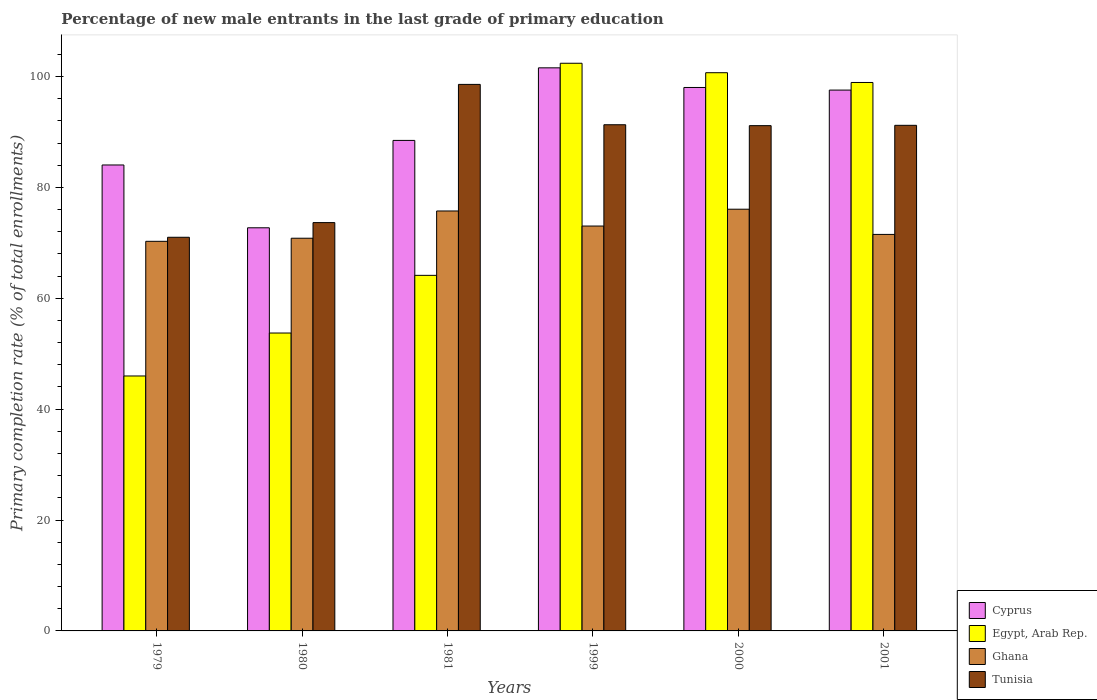How many different coloured bars are there?
Your response must be concise. 4. What is the percentage of new male entrants in Tunisia in 1999?
Give a very brief answer. 91.3. Across all years, what is the maximum percentage of new male entrants in Cyprus?
Ensure brevity in your answer.  101.57. Across all years, what is the minimum percentage of new male entrants in Tunisia?
Provide a short and direct response. 71.01. In which year was the percentage of new male entrants in Cyprus maximum?
Offer a terse response. 1999. In which year was the percentage of new male entrants in Ghana minimum?
Your answer should be compact. 1979. What is the total percentage of new male entrants in Egypt, Arab Rep. in the graph?
Keep it short and to the point. 465.86. What is the difference between the percentage of new male entrants in Tunisia in 1980 and that in 2001?
Your answer should be very brief. -17.55. What is the difference between the percentage of new male entrants in Cyprus in 2000 and the percentage of new male entrants in Egypt, Arab Rep. in 2001?
Offer a terse response. -0.9. What is the average percentage of new male entrants in Cyprus per year?
Ensure brevity in your answer.  90.4. In the year 1999, what is the difference between the percentage of new male entrants in Cyprus and percentage of new male entrants in Ghana?
Provide a succinct answer. 28.54. In how many years, is the percentage of new male entrants in Egypt, Arab Rep. greater than 4 %?
Keep it short and to the point. 6. What is the ratio of the percentage of new male entrants in Tunisia in 1979 to that in 2000?
Give a very brief answer. 0.78. Is the percentage of new male entrants in Ghana in 1980 less than that in 1981?
Your answer should be very brief. Yes. What is the difference between the highest and the second highest percentage of new male entrants in Egypt, Arab Rep.?
Your answer should be compact. 1.71. What is the difference between the highest and the lowest percentage of new male entrants in Ghana?
Give a very brief answer. 5.79. Is it the case that in every year, the sum of the percentage of new male entrants in Ghana and percentage of new male entrants in Cyprus is greater than the sum of percentage of new male entrants in Tunisia and percentage of new male entrants in Egypt, Arab Rep.?
Your answer should be very brief. No. How many bars are there?
Your response must be concise. 24. Are all the bars in the graph horizontal?
Offer a very short reply. No. How many years are there in the graph?
Provide a succinct answer. 6. Are the values on the major ticks of Y-axis written in scientific E-notation?
Your answer should be compact. No. Does the graph contain any zero values?
Ensure brevity in your answer.  No. Where does the legend appear in the graph?
Provide a short and direct response. Bottom right. How many legend labels are there?
Your response must be concise. 4. What is the title of the graph?
Your answer should be very brief. Percentage of new male entrants in the last grade of primary education. Does "Chile" appear as one of the legend labels in the graph?
Ensure brevity in your answer.  No. What is the label or title of the X-axis?
Ensure brevity in your answer.  Years. What is the label or title of the Y-axis?
Your answer should be compact. Primary completion rate (% of total enrollments). What is the Primary completion rate (% of total enrollments) of Cyprus in 1979?
Ensure brevity in your answer.  84.04. What is the Primary completion rate (% of total enrollments) of Egypt, Arab Rep. in 1979?
Your answer should be very brief. 45.99. What is the Primary completion rate (% of total enrollments) of Ghana in 1979?
Give a very brief answer. 70.28. What is the Primary completion rate (% of total enrollments) in Tunisia in 1979?
Provide a succinct answer. 71.01. What is the Primary completion rate (% of total enrollments) of Cyprus in 1980?
Your response must be concise. 72.72. What is the Primary completion rate (% of total enrollments) in Egypt, Arab Rep. in 1980?
Your answer should be very brief. 53.73. What is the Primary completion rate (% of total enrollments) of Ghana in 1980?
Offer a very short reply. 70.83. What is the Primary completion rate (% of total enrollments) in Tunisia in 1980?
Your answer should be very brief. 73.65. What is the Primary completion rate (% of total enrollments) in Cyprus in 1981?
Ensure brevity in your answer.  88.48. What is the Primary completion rate (% of total enrollments) in Egypt, Arab Rep. in 1981?
Provide a succinct answer. 64.14. What is the Primary completion rate (% of total enrollments) of Ghana in 1981?
Offer a terse response. 75.75. What is the Primary completion rate (% of total enrollments) of Tunisia in 1981?
Provide a short and direct response. 98.58. What is the Primary completion rate (% of total enrollments) in Cyprus in 1999?
Your answer should be very brief. 101.57. What is the Primary completion rate (% of total enrollments) of Egypt, Arab Rep. in 1999?
Provide a short and direct response. 102.39. What is the Primary completion rate (% of total enrollments) of Ghana in 1999?
Your answer should be very brief. 73.03. What is the Primary completion rate (% of total enrollments) in Tunisia in 1999?
Ensure brevity in your answer.  91.3. What is the Primary completion rate (% of total enrollments) of Cyprus in 2000?
Give a very brief answer. 98.03. What is the Primary completion rate (% of total enrollments) of Egypt, Arab Rep. in 2000?
Ensure brevity in your answer.  100.69. What is the Primary completion rate (% of total enrollments) of Ghana in 2000?
Keep it short and to the point. 76.07. What is the Primary completion rate (% of total enrollments) in Tunisia in 2000?
Keep it short and to the point. 91.14. What is the Primary completion rate (% of total enrollments) of Cyprus in 2001?
Make the answer very short. 97.55. What is the Primary completion rate (% of total enrollments) of Egypt, Arab Rep. in 2001?
Your response must be concise. 98.93. What is the Primary completion rate (% of total enrollments) of Ghana in 2001?
Give a very brief answer. 71.52. What is the Primary completion rate (% of total enrollments) in Tunisia in 2001?
Provide a succinct answer. 91.2. Across all years, what is the maximum Primary completion rate (% of total enrollments) of Cyprus?
Provide a short and direct response. 101.57. Across all years, what is the maximum Primary completion rate (% of total enrollments) of Egypt, Arab Rep.?
Keep it short and to the point. 102.39. Across all years, what is the maximum Primary completion rate (% of total enrollments) in Ghana?
Your response must be concise. 76.07. Across all years, what is the maximum Primary completion rate (% of total enrollments) in Tunisia?
Keep it short and to the point. 98.58. Across all years, what is the minimum Primary completion rate (% of total enrollments) of Cyprus?
Make the answer very short. 72.72. Across all years, what is the minimum Primary completion rate (% of total enrollments) of Egypt, Arab Rep.?
Make the answer very short. 45.99. Across all years, what is the minimum Primary completion rate (% of total enrollments) of Ghana?
Provide a short and direct response. 70.28. Across all years, what is the minimum Primary completion rate (% of total enrollments) of Tunisia?
Provide a short and direct response. 71.01. What is the total Primary completion rate (% of total enrollments) of Cyprus in the graph?
Offer a very short reply. 542.39. What is the total Primary completion rate (% of total enrollments) in Egypt, Arab Rep. in the graph?
Give a very brief answer. 465.86. What is the total Primary completion rate (% of total enrollments) in Ghana in the graph?
Make the answer very short. 437.48. What is the total Primary completion rate (% of total enrollments) of Tunisia in the graph?
Provide a short and direct response. 516.88. What is the difference between the Primary completion rate (% of total enrollments) of Cyprus in 1979 and that in 1980?
Ensure brevity in your answer.  11.33. What is the difference between the Primary completion rate (% of total enrollments) in Egypt, Arab Rep. in 1979 and that in 1980?
Offer a very short reply. -7.75. What is the difference between the Primary completion rate (% of total enrollments) in Ghana in 1979 and that in 1980?
Keep it short and to the point. -0.56. What is the difference between the Primary completion rate (% of total enrollments) of Tunisia in 1979 and that in 1980?
Your answer should be compact. -2.65. What is the difference between the Primary completion rate (% of total enrollments) of Cyprus in 1979 and that in 1981?
Your answer should be compact. -4.43. What is the difference between the Primary completion rate (% of total enrollments) of Egypt, Arab Rep. in 1979 and that in 1981?
Your answer should be compact. -18.15. What is the difference between the Primary completion rate (% of total enrollments) of Ghana in 1979 and that in 1981?
Offer a terse response. -5.47. What is the difference between the Primary completion rate (% of total enrollments) in Tunisia in 1979 and that in 1981?
Provide a short and direct response. -27.58. What is the difference between the Primary completion rate (% of total enrollments) of Cyprus in 1979 and that in 1999?
Give a very brief answer. -17.52. What is the difference between the Primary completion rate (% of total enrollments) in Egypt, Arab Rep. in 1979 and that in 1999?
Provide a short and direct response. -56.41. What is the difference between the Primary completion rate (% of total enrollments) of Ghana in 1979 and that in 1999?
Your answer should be very brief. -2.76. What is the difference between the Primary completion rate (% of total enrollments) in Tunisia in 1979 and that in 1999?
Give a very brief answer. -20.3. What is the difference between the Primary completion rate (% of total enrollments) of Cyprus in 1979 and that in 2000?
Your response must be concise. -13.98. What is the difference between the Primary completion rate (% of total enrollments) of Egypt, Arab Rep. in 1979 and that in 2000?
Your answer should be compact. -54.7. What is the difference between the Primary completion rate (% of total enrollments) in Ghana in 1979 and that in 2000?
Make the answer very short. -5.79. What is the difference between the Primary completion rate (% of total enrollments) in Tunisia in 1979 and that in 2000?
Give a very brief answer. -20.13. What is the difference between the Primary completion rate (% of total enrollments) of Cyprus in 1979 and that in 2001?
Your answer should be very brief. -13.51. What is the difference between the Primary completion rate (% of total enrollments) of Egypt, Arab Rep. in 1979 and that in 2001?
Your response must be concise. -52.94. What is the difference between the Primary completion rate (% of total enrollments) of Ghana in 1979 and that in 2001?
Make the answer very short. -1.25. What is the difference between the Primary completion rate (% of total enrollments) in Tunisia in 1979 and that in 2001?
Offer a terse response. -20.19. What is the difference between the Primary completion rate (% of total enrollments) in Cyprus in 1980 and that in 1981?
Provide a succinct answer. -15.76. What is the difference between the Primary completion rate (% of total enrollments) of Egypt, Arab Rep. in 1980 and that in 1981?
Offer a terse response. -10.4. What is the difference between the Primary completion rate (% of total enrollments) in Ghana in 1980 and that in 1981?
Your answer should be very brief. -4.92. What is the difference between the Primary completion rate (% of total enrollments) in Tunisia in 1980 and that in 1981?
Provide a succinct answer. -24.93. What is the difference between the Primary completion rate (% of total enrollments) in Cyprus in 1980 and that in 1999?
Offer a very short reply. -28.85. What is the difference between the Primary completion rate (% of total enrollments) in Egypt, Arab Rep. in 1980 and that in 1999?
Ensure brevity in your answer.  -48.66. What is the difference between the Primary completion rate (% of total enrollments) of Ghana in 1980 and that in 1999?
Provide a short and direct response. -2.2. What is the difference between the Primary completion rate (% of total enrollments) in Tunisia in 1980 and that in 1999?
Your answer should be compact. -17.65. What is the difference between the Primary completion rate (% of total enrollments) of Cyprus in 1980 and that in 2000?
Keep it short and to the point. -25.31. What is the difference between the Primary completion rate (% of total enrollments) of Egypt, Arab Rep. in 1980 and that in 2000?
Offer a terse response. -46.95. What is the difference between the Primary completion rate (% of total enrollments) of Ghana in 1980 and that in 2000?
Provide a succinct answer. -5.23. What is the difference between the Primary completion rate (% of total enrollments) of Tunisia in 1980 and that in 2000?
Offer a very short reply. -17.49. What is the difference between the Primary completion rate (% of total enrollments) in Cyprus in 1980 and that in 2001?
Provide a succinct answer. -24.84. What is the difference between the Primary completion rate (% of total enrollments) in Egypt, Arab Rep. in 1980 and that in 2001?
Provide a succinct answer. -45.19. What is the difference between the Primary completion rate (% of total enrollments) in Ghana in 1980 and that in 2001?
Provide a succinct answer. -0.69. What is the difference between the Primary completion rate (% of total enrollments) of Tunisia in 1980 and that in 2001?
Your answer should be very brief. -17.55. What is the difference between the Primary completion rate (% of total enrollments) of Cyprus in 1981 and that in 1999?
Your answer should be very brief. -13.09. What is the difference between the Primary completion rate (% of total enrollments) in Egypt, Arab Rep. in 1981 and that in 1999?
Offer a very short reply. -38.26. What is the difference between the Primary completion rate (% of total enrollments) of Ghana in 1981 and that in 1999?
Keep it short and to the point. 2.72. What is the difference between the Primary completion rate (% of total enrollments) in Tunisia in 1981 and that in 1999?
Ensure brevity in your answer.  7.28. What is the difference between the Primary completion rate (% of total enrollments) of Cyprus in 1981 and that in 2000?
Offer a very short reply. -9.55. What is the difference between the Primary completion rate (% of total enrollments) in Egypt, Arab Rep. in 1981 and that in 2000?
Give a very brief answer. -36.55. What is the difference between the Primary completion rate (% of total enrollments) of Ghana in 1981 and that in 2000?
Your answer should be very brief. -0.32. What is the difference between the Primary completion rate (% of total enrollments) in Tunisia in 1981 and that in 2000?
Offer a very short reply. 7.44. What is the difference between the Primary completion rate (% of total enrollments) of Cyprus in 1981 and that in 2001?
Provide a short and direct response. -9.08. What is the difference between the Primary completion rate (% of total enrollments) of Egypt, Arab Rep. in 1981 and that in 2001?
Give a very brief answer. -34.79. What is the difference between the Primary completion rate (% of total enrollments) of Ghana in 1981 and that in 2001?
Offer a very short reply. 4.23. What is the difference between the Primary completion rate (% of total enrollments) of Tunisia in 1981 and that in 2001?
Offer a very short reply. 7.38. What is the difference between the Primary completion rate (% of total enrollments) of Cyprus in 1999 and that in 2000?
Give a very brief answer. 3.54. What is the difference between the Primary completion rate (% of total enrollments) of Egypt, Arab Rep. in 1999 and that in 2000?
Ensure brevity in your answer.  1.71. What is the difference between the Primary completion rate (% of total enrollments) in Ghana in 1999 and that in 2000?
Provide a succinct answer. -3.03. What is the difference between the Primary completion rate (% of total enrollments) of Tunisia in 1999 and that in 2000?
Your response must be concise. 0.16. What is the difference between the Primary completion rate (% of total enrollments) of Cyprus in 1999 and that in 2001?
Give a very brief answer. 4.01. What is the difference between the Primary completion rate (% of total enrollments) in Egypt, Arab Rep. in 1999 and that in 2001?
Ensure brevity in your answer.  3.47. What is the difference between the Primary completion rate (% of total enrollments) in Ghana in 1999 and that in 2001?
Your response must be concise. 1.51. What is the difference between the Primary completion rate (% of total enrollments) in Tunisia in 1999 and that in 2001?
Give a very brief answer. 0.1. What is the difference between the Primary completion rate (% of total enrollments) of Cyprus in 2000 and that in 2001?
Provide a succinct answer. 0.47. What is the difference between the Primary completion rate (% of total enrollments) in Egypt, Arab Rep. in 2000 and that in 2001?
Provide a short and direct response. 1.76. What is the difference between the Primary completion rate (% of total enrollments) of Ghana in 2000 and that in 2001?
Offer a terse response. 4.54. What is the difference between the Primary completion rate (% of total enrollments) in Tunisia in 2000 and that in 2001?
Your answer should be compact. -0.06. What is the difference between the Primary completion rate (% of total enrollments) of Cyprus in 1979 and the Primary completion rate (% of total enrollments) of Egypt, Arab Rep. in 1980?
Make the answer very short. 30.31. What is the difference between the Primary completion rate (% of total enrollments) of Cyprus in 1979 and the Primary completion rate (% of total enrollments) of Ghana in 1980?
Offer a very short reply. 13.21. What is the difference between the Primary completion rate (% of total enrollments) of Cyprus in 1979 and the Primary completion rate (% of total enrollments) of Tunisia in 1980?
Your answer should be very brief. 10.39. What is the difference between the Primary completion rate (% of total enrollments) of Egypt, Arab Rep. in 1979 and the Primary completion rate (% of total enrollments) of Ghana in 1980?
Give a very brief answer. -24.85. What is the difference between the Primary completion rate (% of total enrollments) of Egypt, Arab Rep. in 1979 and the Primary completion rate (% of total enrollments) of Tunisia in 1980?
Ensure brevity in your answer.  -27.67. What is the difference between the Primary completion rate (% of total enrollments) in Ghana in 1979 and the Primary completion rate (% of total enrollments) in Tunisia in 1980?
Your answer should be compact. -3.38. What is the difference between the Primary completion rate (% of total enrollments) in Cyprus in 1979 and the Primary completion rate (% of total enrollments) in Egypt, Arab Rep. in 1981?
Ensure brevity in your answer.  19.91. What is the difference between the Primary completion rate (% of total enrollments) of Cyprus in 1979 and the Primary completion rate (% of total enrollments) of Ghana in 1981?
Your response must be concise. 8.3. What is the difference between the Primary completion rate (% of total enrollments) of Cyprus in 1979 and the Primary completion rate (% of total enrollments) of Tunisia in 1981?
Your answer should be compact. -14.54. What is the difference between the Primary completion rate (% of total enrollments) in Egypt, Arab Rep. in 1979 and the Primary completion rate (% of total enrollments) in Ghana in 1981?
Your response must be concise. -29.76. What is the difference between the Primary completion rate (% of total enrollments) in Egypt, Arab Rep. in 1979 and the Primary completion rate (% of total enrollments) in Tunisia in 1981?
Provide a succinct answer. -52.6. What is the difference between the Primary completion rate (% of total enrollments) of Ghana in 1979 and the Primary completion rate (% of total enrollments) of Tunisia in 1981?
Offer a very short reply. -28.31. What is the difference between the Primary completion rate (% of total enrollments) in Cyprus in 1979 and the Primary completion rate (% of total enrollments) in Egypt, Arab Rep. in 1999?
Provide a succinct answer. -18.35. What is the difference between the Primary completion rate (% of total enrollments) in Cyprus in 1979 and the Primary completion rate (% of total enrollments) in Ghana in 1999?
Provide a short and direct response. 11.01. What is the difference between the Primary completion rate (% of total enrollments) of Cyprus in 1979 and the Primary completion rate (% of total enrollments) of Tunisia in 1999?
Keep it short and to the point. -7.26. What is the difference between the Primary completion rate (% of total enrollments) of Egypt, Arab Rep. in 1979 and the Primary completion rate (% of total enrollments) of Ghana in 1999?
Offer a terse response. -27.05. What is the difference between the Primary completion rate (% of total enrollments) in Egypt, Arab Rep. in 1979 and the Primary completion rate (% of total enrollments) in Tunisia in 1999?
Offer a very short reply. -45.32. What is the difference between the Primary completion rate (% of total enrollments) in Ghana in 1979 and the Primary completion rate (% of total enrollments) in Tunisia in 1999?
Keep it short and to the point. -21.03. What is the difference between the Primary completion rate (% of total enrollments) in Cyprus in 1979 and the Primary completion rate (% of total enrollments) in Egypt, Arab Rep. in 2000?
Provide a short and direct response. -16.64. What is the difference between the Primary completion rate (% of total enrollments) in Cyprus in 1979 and the Primary completion rate (% of total enrollments) in Ghana in 2000?
Keep it short and to the point. 7.98. What is the difference between the Primary completion rate (% of total enrollments) in Cyprus in 1979 and the Primary completion rate (% of total enrollments) in Tunisia in 2000?
Make the answer very short. -7.09. What is the difference between the Primary completion rate (% of total enrollments) of Egypt, Arab Rep. in 1979 and the Primary completion rate (% of total enrollments) of Ghana in 2000?
Ensure brevity in your answer.  -30.08. What is the difference between the Primary completion rate (% of total enrollments) of Egypt, Arab Rep. in 1979 and the Primary completion rate (% of total enrollments) of Tunisia in 2000?
Offer a terse response. -45.15. What is the difference between the Primary completion rate (% of total enrollments) of Ghana in 1979 and the Primary completion rate (% of total enrollments) of Tunisia in 2000?
Offer a very short reply. -20.86. What is the difference between the Primary completion rate (% of total enrollments) in Cyprus in 1979 and the Primary completion rate (% of total enrollments) in Egypt, Arab Rep. in 2001?
Provide a succinct answer. -14.88. What is the difference between the Primary completion rate (% of total enrollments) of Cyprus in 1979 and the Primary completion rate (% of total enrollments) of Ghana in 2001?
Offer a terse response. 12.52. What is the difference between the Primary completion rate (% of total enrollments) in Cyprus in 1979 and the Primary completion rate (% of total enrollments) in Tunisia in 2001?
Offer a terse response. -7.16. What is the difference between the Primary completion rate (% of total enrollments) in Egypt, Arab Rep. in 1979 and the Primary completion rate (% of total enrollments) in Ghana in 2001?
Provide a succinct answer. -25.54. What is the difference between the Primary completion rate (% of total enrollments) of Egypt, Arab Rep. in 1979 and the Primary completion rate (% of total enrollments) of Tunisia in 2001?
Provide a succinct answer. -45.21. What is the difference between the Primary completion rate (% of total enrollments) in Ghana in 1979 and the Primary completion rate (% of total enrollments) in Tunisia in 2001?
Your response must be concise. -20.92. What is the difference between the Primary completion rate (% of total enrollments) in Cyprus in 1980 and the Primary completion rate (% of total enrollments) in Egypt, Arab Rep. in 1981?
Ensure brevity in your answer.  8.58. What is the difference between the Primary completion rate (% of total enrollments) in Cyprus in 1980 and the Primary completion rate (% of total enrollments) in Ghana in 1981?
Make the answer very short. -3.03. What is the difference between the Primary completion rate (% of total enrollments) of Cyprus in 1980 and the Primary completion rate (% of total enrollments) of Tunisia in 1981?
Provide a succinct answer. -25.86. What is the difference between the Primary completion rate (% of total enrollments) in Egypt, Arab Rep. in 1980 and the Primary completion rate (% of total enrollments) in Ghana in 1981?
Ensure brevity in your answer.  -22.01. What is the difference between the Primary completion rate (% of total enrollments) of Egypt, Arab Rep. in 1980 and the Primary completion rate (% of total enrollments) of Tunisia in 1981?
Ensure brevity in your answer.  -44.85. What is the difference between the Primary completion rate (% of total enrollments) of Ghana in 1980 and the Primary completion rate (% of total enrollments) of Tunisia in 1981?
Make the answer very short. -27.75. What is the difference between the Primary completion rate (% of total enrollments) in Cyprus in 1980 and the Primary completion rate (% of total enrollments) in Egypt, Arab Rep. in 1999?
Make the answer very short. -29.68. What is the difference between the Primary completion rate (% of total enrollments) of Cyprus in 1980 and the Primary completion rate (% of total enrollments) of Ghana in 1999?
Provide a short and direct response. -0.32. What is the difference between the Primary completion rate (% of total enrollments) in Cyprus in 1980 and the Primary completion rate (% of total enrollments) in Tunisia in 1999?
Your answer should be very brief. -18.59. What is the difference between the Primary completion rate (% of total enrollments) of Egypt, Arab Rep. in 1980 and the Primary completion rate (% of total enrollments) of Ghana in 1999?
Your answer should be very brief. -19.3. What is the difference between the Primary completion rate (% of total enrollments) in Egypt, Arab Rep. in 1980 and the Primary completion rate (% of total enrollments) in Tunisia in 1999?
Your answer should be compact. -37.57. What is the difference between the Primary completion rate (% of total enrollments) in Ghana in 1980 and the Primary completion rate (% of total enrollments) in Tunisia in 1999?
Provide a short and direct response. -20.47. What is the difference between the Primary completion rate (% of total enrollments) in Cyprus in 1980 and the Primary completion rate (% of total enrollments) in Egypt, Arab Rep. in 2000?
Offer a terse response. -27.97. What is the difference between the Primary completion rate (% of total enrollments) of Cyprus in 1980 and the Primary completion rate (% of total enrollments) of Ghana in 2000?
Your response must be concise. -3.35. What is the difference between the Primary completion rate (% of total enrollments) in Cyprus in 1980 and the Primary completion rate (% of total enrollments) in Tunisia in 2000?
Provide a short and direct response. -18.42. What is the difference between the Primary completion rate (% of total enrollments) in Egypt, Arab Rep. in 1980 and the Primary completion rate (% of total enrollments) in Ghana in 2000?
Offer a terse response. -22.33. What is the difference between the Primary completion rate (% of total enrollments) in Egypt, Arab Rep. in 1980 and the Primary completion rate (% of total enrollments) in Tunisia in 2000?
Ensure brevity in your answer.  -37.41. What is the difference between the Primary completion rate (% of total enrollments) in Ghana in 1980 and the Primary completion rate (% of total enrollments) in Tunisia in 2000?
Give a very brief answer. -20.31. What is the difference between the Primary completion rate (% of total enrollments) of Cyprus in 1980 and the Primary completion rate (% of total enrollments) of Egypt, Arab Rep. in 2001?
Ensure brevity in your answer.  -26.21. What is the difference between the Primary completion rate (% of total enrollments) of Cyprus in 1980 and the Primary completion rate (% of total enrollments) of Ghana in 2001?
Make the answer very short. 1.19. What is the difference between the Primary completion rate (% of total enrollments) of Cyprus in 1980 and the Primary completion rate (% of total enrollments) of Tunisia in 2001?
Give a very brief answer. -18.48. What is the difference between the Primary completion rate (% of total enrollments) in Egypt, Arab Rep. in 1980 and the Primary completion rate (% of total enrollments) in Ghana in 2001?
Make the answer very short. -17.79. What is the difference between the Primary completion rate (% of total enrollments) of Egypt, Arab Rep. in 1980 and the Primary completion rate (% of total enrollments) of Tunisia in 2001?
Make the answer very short. -37.47. What is the difference between the Primary completion rate (% of total enrollments) of Ghana in 1980 and the Primary completion rate (% of total enrollments) of Tunisia in 2001?
Offer a very short reply. -20.37. What is the difference between the Primary completion rate (% of total enrollments) in Cyprus in 1981 and the Primary completion rate (% of total enrollments) in Egypt, Arab Rep. in 1999?
Ensure brevity in your answer.  -13.92. What is the difference between the Primary completion rate (% of total enrollments) in Cyprus in 1981 and the Primary completion rate (% of total enrollments) in Ghana in 1999?
Your answer should be compact. 15.44. What is the difference between the Primary completion rate (% of total enrollments) of Cyprus in 1981 and the Primary completion rate (% of total enrollments) of Tunisia in 1999?
Give a very brief answer. -2.83. What is the difference between the Primary completion rate (% of total enrollments) in Egypt, Arab Rep. in 1981 and the Primary completion rate (% of total enrollments) in Ghana in 1999?
Your answer should be very brief. -8.9. What is the difference between the Primary completion rate (% of total enrollments) in Egypt, Arab Rep. in 1981 and the Primary completion rate (% of total enrollments) in Tunisia in 1999?
Your answer should be very brief. -27.17. What is the difference between the Primary completion rate (% of total enrollments) of Ghana in 1981 and the Primary completion rate (% of total enrollments) of Tunisia in 1999?
Give a very brief answer. -15.55. What is the difference between the Primary completion rate (% of total enrollments) in Cyprus in 1981 and the Primary completion rate (% of total enrollments) in Egypt, Arab Rep. in 2000?
Keep it short and to the point. -12.21. What is the difference between the Primary completion rate (% of total enrollments) of Cyprus in 1981 and the Primary completion rate (% of total enrollments) of Ghana in 2000?
Your answer should be very brief. 12.41. What is the difference between the Primary completion rate (% of total enrollments) in Cyprus in 1981 and the Primary completion rate (% of total enrollments) in Tunisia in 2000?
Your answer should be very brief. -2.66. What is the difference between the Primary completion rate (% of total enrollments) in Egypt, Arab Rep. in 1981 and the Primary completion rate (% of total enrollments) in Ghana in 2000?
Make the answer very short. -11.93. What is the difference between the Primary completion rate (% of total enrollments) of Egypt, Arab Rep. in 1981 and the Primary completion rate (% of total enrollments) of Tunisia in 2000?
Your answer should be compact. -27. What is the difference between the Primary completion rate (% of total enrollments) in Ghana in 1981 and the Primary completion rate (% of total enrollments) in Tunisia in 2000?
Keep it short and to the point. -15.39. What is the difference between the Primary completion rate (% of total enrollments) of Cyprus in 1981 and the Primary completion rate (% of total enrollments) of Egypt, Arab Rep. in 2001?
Give a very brief answer. -10.45. What is the difference between the Primary completion rate (% of total enrollments) of Cyprus in 1981 and the Primary completion rate (% of total enrollments) of Ghana in 2001?
Provide a succinct answer. 16.95. What is the difference between the Primary completion rate (% of total enrollments) in Cyprus in 1981 and the Primary completion rate (% of total enrollments) in Tunisia in 2001?
Your answer should be compact. -2.72. What is the difference between the Primary completion rate (% of total enrollments) of Egypt, Arab Rep. in 1981 and the Primary completion rate (% of total enrollments) of Ghana in 2001?
Offer a terse response. -7.39. What is the difference between the Primary completion rate (% of total enrollments) in Egypt, Arab Rep. in 1981 and the Primary completion rate (% of total enrollments) in Tunisia in 2001?
Your answer should be compact. -27.06. What is the difference between the Primary completion rate (% of total enrollments) in Ghana in 1981 and the Primary completion rate (% of total enrollments) in Tunisia in 2001?
Offer a very short reply. -15.45. What is the difference between the Primary completion rate (% of total enrollments) of Cyprus in 1999 and the Primary completion rate (% of total enrollments) of Egypt, Arab Rep. in 2000?
Keep it short and to the point. 0.88. What is the difference between the Primary completion rate (% of total enrollments) in Cyprus in 1999 and the Primary completion rate (% of total enrollments) in Ghana in 2000?
Offer a very short reply. 25.5. What is the difference between the Primary completion rate (% of total enrollments) in Cyprus in 1999 and the Primary completion rate (% of total enrollments) in Tunisia in 2000?
Provide a short and direct response. 10.43. What is the difference between the Primary completion rate (% of total enrollments) in Egypt, Arab Rep. in 1999 and the Primary completion rate (% of total enrollments) in Ghana in 2000?
Your answer should be compact. 26.33. What is the difference between the Primary completion rate (% of total enrollments) in Egypt, Arab Rep. in 1999 and the Primary completion rate (% of total enrollments) in Tunisia in 2000?
Your answer should be compact. 11.25. What is the difference between the Primary completion rate (% of total enrollments) of Ghana in 1999 and the Primary completion rate (% of total enrollments) of Tunisia in 2000?
Ensure brevity in your answer.  -18.11. What is the difference between the Primary completion rate (% of total enrollments) in Cyprus in 1999 and the Primary completion rate (% of total enrollments) in Egypt, Arab Rep. in 2001?
Your response must be concise. 2.64. What is the difference between the Primary completion rate (% of total enrollments) of Cyprus in 1999 and the Primary completion rate (% of total enrollments) of Ghana in 2001?
Your response must be concise. 30.05. What is the difference between the Primary completion rate (% of total enrollments) of Cyprus in 1999 and the Primary completion rate (% of total enrollments) of Tunisia in 2001?
Provide a short and direct response. 10.37. What is the difference between the Primary completion rate (% of total enrollments) of Egypt, Arab Rep. in 1999 and the Primary completion rate (% of total enrollments) of Ghana in 2001?
Provide a short and direct response. 30.87. What is the difference between the Primary completion rate (% of total enrollments) in Egypt, Arab Rep. in 1999 and the Primary completion rate (% of total enrollments) in Tunisia in 2001?
Offer a terse response. 11.19. What is the difference between the Primary completion rate (% of total enrollments) in Ghana in 1999 and the Primary completion rate (% of total enrollments) in Tunisia in 2001?
Offer a terse response. -18.17. What is the difference between the Primary completion rate (% of total enrollments) in Cyprus in 2000 and the Primary completion rate (% of total enrollments) in Egypt, Arab Rep. in 2001?
Your response must be concise. -0.9. What is the difference between the Primary completion rate (% of total enrollments) in Cyprus in 2000 and the Primary completion rate (% of total enrollments) in Ghana in 2001?
Your answer should be compact. 26.5. What is the difference between the Primary completion rate (% of total enrollments) of Cyprus in 2000 and the Primary completion rate (% of total enrollments) of Tunisia in 2001?
Ensure brevity in your answer.  6.83. What is the difference between the Primary completion rate (% of total enrollments) of Egypt, Arab Rep. in 2000 and the Primary completion rate (% of total enrollments) of Ghana in 2001?
Your answer should be compact. 29.17. What is the difference between the Primary completion rate (% of total enrollments) of Egypt, Arab Rep. in 2000 and the Primary completion rate (% of total enrollments) of Tunisia in 2001?
Offer a very short reply. 9.49. What is the difference between the Primary completion rate (% of total enrollments) of Ghana in 2000 and the Primary completion rate (% of total enrollments) of Tunisia in 2001?
Keep it short and to the point. -15.13. What is the average Primary completion rate (% of total enrollments) in Cyprus per year?
Your answer should be very brief. 90.4. What is the average Primary completion rate (% of total enrollments) of Egypt, Arab Rep. per year?
Keep it short and to the point. 77.64. What is the average Primary completion rate (% of total enrollments) of Ghana per year?
Your response must be concise. 72.91. What is the average Primary completion rate (% of total enrollments) of Tunisia per year?
Your answer should be very brief. 86.15. In the year 1979, what is the difference between the Primary completion rate (% of total enrollments) of Cyprus and Primary completion rate (% of total enrollments) of Egypt, Arab Rep.?
Ensure brevity in your answer.  38.06. In the year 1979, what is the difference between the Primary completion rate (% of total enrollments) in Cyprus and Primary completion rate (% of total enrollments) in Ghana?
Offer a terse response. 13.77. In the year 1979, what is the difference between the Primary completion rate (% of total enrollments) of Cyprus and Primary completion rate (% of total enrollments) of Tunisia?
Your response must be concise. 13.04. In the year 1979, what is the difference between the Primary completion rate (% of total enrollments) of Egypt, Arab Rep. and Primary completion rate (% of total enrollments) of Ghana?
Your answer should be compact. -24.29. In the year 1979, what is the difference between the Primary completion rate (% of total enrollments) in Egypt, Arab Rep. and Primary completion rate (% of total enrollments) in Tunisia?
Give a very brief answer. -25.02. In the year 1979, what is the difference between the Primary completion rate (% of total enrollments) of Ghana and Primary completion rate (% of total enrollments) of Tunisia?
Your answer should be very brief. -0.73. In the year 1980, what is the difference between the Primary completion rate (% of total enrollments) in Cyprus and Primary completion rate (% of total enrollments) in Egypt, Arab Rep.?
Offer a terse response. 18.98. In the year 1980, what is the difference between the Primary completion rate (% of total enrollments) of Cyprus and Primary completion rate (% of total enrollments) of Ghana?
Give a very brief answer. 1.88. In the year 1980, what is the difference between the Primary completion rate (% of total enrollments) in Cyprus and Primary completion rate (% of total enrollments) in Tunisia?
Ensure brevity in your answer.  -0.94. In the year 1980, what is the difference between the Primary completion rate (% of total enrollments) of Egypt, Arab Rep. and Primary completion rate (% of total enrollments) of Ghana?
Make the answer very short. -17.1. In the year 1980, what is the difference between the Primary completion rate (% of total enrollments) of Egypt, Arab Rep. and Primary completion rate (% of total enrollments) of Tunisia?
Offer a very short reply. -19.92. In the year 1980, what is the difference between the Primary completion rate (% of total enrollments) of Ghana and Primary completion rate (% of total enrollments) of Tunisia?
Keep it short and to the point. -2.82. In the year 1981, what is the difference between the Primary completion rate (% of total enrollments) in Cyprus and Primary completion rate (% of total enrollments) in Egypt, Arab Rep.?
Provide a short and direct response. 24.34. In the year 1981, what is the difference between the Primary completion rate (% of total enrollments) of Cyprus and Primary completion rate (% of total enrollments) of Ghana?
Your answer should be compact. 12.73. In the year 1981, what is the difference between the Primary completion rate (% of total enrollments) of Cyprus and Primary completion rate (% of total enrollments) of Tunisia?
Offer a terse response. -10.11. In the year 1981, what is the difference between the Primary completion rate (% of total enrollments) of Egypt, Arab Rep. and Primary completion rate (% of total enrollments) of Ghana?
Provide a short and direct response. -11.61. In the year 1981, what is the difference between the Primary completion rate (% of total enrollments) of Egypt, Arab Rep. and Primary completion rate (% of total enrollments) of Tunisia?
Give a very brief answer. -34.45. In the year 1981, what is the difference between the Primary completion rate (% of total enrollments) of Ghana and Primary completion rate (% of total enrollments) of Tunisia?
Your answer should be very brief. -22.83. In the year 1999, what is the difference between the Primary completion rate (% of total enrollments) of Cyprus and Primary completion rate (% of total enrollments) of Egypt, Arab Rep.?
Your response must be concise. -0.82. In the year 1999, what is the difference between the Primary completion rate (% of total enrollments) of Cyprus and Primary completion rate (% of total enrollments) of Ghana?
Your response must be concise. 28.54. In the year 1999, what is the difference between the Primary completion rate (% of total enrollments) in Cyprus and Primary completion rate (% of total enrollments) in Tunisia?
Provide a succinct answer. 10.27. In the year 1999, what is the difference between the Primary completion rate (% of total enrollments) in Egypt, Arab Rep. and Primary completion rate (% of total enrollments) in Ghana?
Your answer should be compact. 29.36. In the year 1999, what is the difference between the Primary completion rate (% of total enrollments) of Egypt, Arab Rep. and Primary completion rate (% of total enrollments) of Tunisia?
Provide a succinct answer. 11.09. In the year 1999, what is the difference between the Primary completion rate (% of total enrollments) in Ghana and Primary completion rate (% of total enrollments) in Tunisia?
Offer a very short reply. -18.27. In the year 2000, what is the difference between the Primary completion rate (% of total enrollments) in Cyprus and Primary completion rate (% of total enrollments) in Egypt, Arab Rep.?
Keep it short and to the point. -2.66. In the year 2000, what is the difference between the Primary completion rate (% of total enrollments) of Cyprus and Primary completion rate (% of total enrollments) of Ghana?
Ensure brevity in your answer.  21.96. In the year 2000, what is the difference between the Primary completion rate (% of total enrollments) of Cyprus and Primary completion rate (% of total enrollments) of Tunisia?
Give a very brief answer. 6.89. In the year 2000, what is the difference between the Primary completion rate (% of total enrollments) in Egypt, Arab Rep. and Primary completion rate (% of total enrollments) in Ghana?
Offer a very short reply. 24.62. In the year 2000, what is the difference between the Primary completion rate (% of total enrollments) of Egypt, Arab Rep. and Primary completion rate (% of total enrollments) of Tunisia?
Ensure brevity in your answer.  9.55. In the year 2000, what is the difference between the Primary completion rate (% of total enrollments) of Ghana and Primary completion rate (% of total enrollments) of Tunisia?
Keep it short and to the point. -15.07. In the year 2001, what is the difference between the Primary completion rate (% of total enrollments) in Cyprus and Primary completion rate (% of total enrollments) in Egypt, Arab Rep.?
Your answer should be very brief. -1.37. In the year 2001, what is the difference between the Primary completion rate (% of total enrollments) of Cyprus and Primary completion rate (% of total enrollments) of Ghana?
Keep it short and to the point. 26.03. In the year 2001, what is the difference between the Primary completion rate (% of total enrollments) in Cyprus and Primary completion rate (% of total enrollments) in Tunisia?
Ensure brevity in your answer.  6.35. In the year 2001, what is the difference between the Primary completion rate (% of total enrollments) of Egypt, Arab Rep. and Primary completion rate (% of total enrollments) of Ghana?
Offer a terse response. 27.41. In the year 2001, what is the difference between the Primary completion rate (% of total enrollments) in Egypt, Arab Rep. and Primary completion rate (% of total enrollments) in Tunisia?
Give a very brief answer. 7.73. In the year 2001, what is the difference between the Primary completion rate (% of total enrollments) of Ghana and Primary completion rate (% of total enrollments) of Tunisia?
Your answer should be very brief. -19.68. What is the ratio of the Primary completion rate (% of total enrollments) in Cyprus in 1979 to that in 1980?
Provide a short and direct response. 1.16. What is the ratio of the Primary completion rate (% of total enrollments) in Egypt, Arab Rep. in 1979 to that in 1980?
Provide a succinct answer. 0.86. What is the ratio of the Primary completion rate (% of total enrollments) in Ghana in 1979 to that in 1980?
Your answer should be very brief. 0.99. What is the ratio of the Primary completion rate (% of total enrollments) in Tunisia in 1979 to that in 1980?
Your answer should be compact. 0.96. What is the ratio of the Primary completion rate (% of total enrollments) in Cyprus in 1979 to that in 1981?
Provide a succinct answer. 0.95. What is the ratio of the Primary completion rate (% of total enrollments) in Egypt, Arab Rep. in 1979 to that in 1981?
Provide a short and direct response. 0.72. What is the ratio of the Primary completion rate (% of total enrollments) in Ghana in 1979 to that in 1981?
Make the answer very short. 0.93. What is the ratio of the Primary completion rate (% of total enrollments) in Tunisia in 1979 to that in 1981?
Provide a succinct answer. 0.72. What is the ratio of the Primary completion rate (% of total enrollments) in Cyprus in 1979 to that in 1999?
Offer a terse response. 0.83. What is the ratio of the Primary completion rate (% of total enrollments) in Egypt, Arab Rep. in 1979 to that in 1999?
Your answer should be compact. 0.45. What is the ratio of the Primary completion rate (% of total enrollments) in Ghana in 1979 to that in 1999?
Offer a terse response. 0.96. What is the ratio of the Primary completion rate (% of total enrollments) in Tunisia in 1979 to that in 1999?
Your response must be concise. 0.78. What is the ratio of the Primary completion rate (% of total enrollments) of Cyprus in 1979 to that in 2000?
Ensure brevity in your answer.  0.86. What is the ratio of the Primary completion rate (% of total enrollments) of Egypt, Arab Rep. in 1979 to that in 2000?
Keep it short and to the point. 0.46. What is the ratio of the Primary completion rate (% of total enrollments) of Ghana in 1979 to that in 2000?
Offer a terse response. 0.92. What is the ratio of the Primary completion rate (% of total enrollments) of Tunisia in 1979 to that in 2000?
Ensure brevity in your answer.  0.78. What is the ratio of the Primary completion rate (% of total enrollments) of Cyprus in 1979 to that in 2001?
Offer a very short reply. 0.86. What is the ratio of the Primary completion rate (% of total enrollments) in Egypt, Arab Rep. in 1979 to that in 2001?
Give a very brief answer. 0.46. What is the ratio of the Primary completion rate (% of total enrollments) in Ghana in 1979 to that in 2001?
Offer a very short reply. 0.98. What is the ratio of the Primary completion rate (% of total enrollments) in Tunisia in 1979 to that in 2001?
Ensure brevity in your answer.  0.78. What is the ratio of the Primary completion rate (% of total enrollments) of Cyprus in 1980 to that in 1981?
Provide a succinct answer. 0.82. What is the ratio of the Primary completion rate (% of total enrollments) of Egypt, Arab Rep. in 1980 to that in 1981?
Keep it short and to the point. 0.84. What is the ratio of the Primary completion rate (% of total enrollments) of Ghana in 1980 to that in 1981?
Your answer should be compact. 0.94. What is the ratio of the Primary completion rate (% of total enrollments) in Tunisia in 1980 to that in 1981?
Provide a succinct answer. 0.75. What is the ratio of the Primary completion rate (% of total enrollments) of Cyprus in 1980 to that in 1999?
Offer a very short reply. 0.72. What is the ratio of the Primary completion rate (% of total enrollments) of Egypt, Arab Rep. in 1980 to that in 1999?
Keep it short and to the point. 0.52. What is the ratio of the Primary completion rate (% of total enrollments) of Ghana in 1980 to that in 1999?
Your response must be concise. 0.97. What is the ratio of the Primary completion rate (% of total enrollments) in Tunisia in 1980 to that in 1999?
Keep it short and to the point. 0.81. What is the ratio of the Primary completion rate (% of total enrollments) in Cyprus in 1980 to that in 2000?
Ensure brevity in your answer.  0.74. What is the ratio of the Primary completion rate (% of total enrollments) in Egypt, Arab Rep. in 1980 to that in 2000?
Your answer should be very brief. 0.53. What is the ratio of the Primary completion rate (% of total enrollments) in Ghana in 1980 to that in 2000?
Give a very brief answer. 0.93. What is the ratio of the Primary completion rate (% of total enrollments) of Tunisia in 1980 to that in 2000?
Your answer should be compact. 0.81. What is the ratio of the Primary completion rate (% of total enrollments) of Cyprus in 1980 to that in 2001?
Provide a short and direct response. 0.75. What is the ratio of the Primary completion rate (% of total enrollments) of Egypt, Arab Rep. in 1980 to that in 2001?
Your answer should be very brief. 0.54. What is the ratio of the Primary completion rate (% of total enrollments) of Tunisia in 1980 to that in 2001?
Provide a succinct answer. 0.81. What is the ratio of the Primary completion rate (% of total enrollments) in Cyprus in 1981 to that in 1999?
Give a very brief answer. 0.87. What is the ratio of the Primary completion rate (% of total enrollments) of Egypt, Arab Rep. in 1981 to that in 1999?
Provide a short and direct response. 0.63. What is the ratio of the Primary completion rate (% of total enrollments) of Ghana in 1981 to that in 1999?
Your answer should be very brief. 1.04. What is the ratio of the Primary completion rate (% of total enrollments) of Tunisia in 1981 to that in 1999?
Offer a terse response. 1.08. What is the ratio of the Primary completion rate (% of total enrollments) of Cyprus in 1981 to that in 2000?
Your answer should be very brief. 0.9. What is the ratio of the Primary completion rate (% of total enrollments) of Egypt, Arab Rep. in 1981 to that in 2000?
Provide a short and direct response. 0.64. What is the ratio of the Primary completion rate (% of total enrollments) in Ghana in 1981 to that in 2000?
Offer a terse response. 1. What is the ratio of the Primary completion rate (% of total enrollments) in Tunisia in 1981 to that in 2000?
Your response must be concise. 1.08. What is the ratio of the Primary completion rate (% of total enrollments) in Cyprus in 1981 to that in 2001?
Ensure brevity in your answer.  0.91. What is the ratio of the Primary completion rate (% of total enrollments) in Egypt, Arab Rep. in 1981 to that in 2001?
Make the answer very short. 0.65. What is the ratio of the Primary completion rate (% of total enrollments) in Ghana in 1981 to that in 2001?
Your answer should be very brief. 1.06. What is the ratio of the Primary completion rate (% of total enrollments) of Tunisia in 1981 to that in 2001?
Your response must be concise. 1.08. What is the ratio of the Primary completion rate (% of total enrollments) of Cyprus in 1999 to that in 2000?
Keep it short and to the point. 1.04. What is the ratio of the Primary completion rate (% of total enrollments) of Egypt, Arab Rep. in 1999 to that in 2000?
Offer a terse response. 1.02. What is the ratio of the Primary completion rate (% of total enrollments) in Ghana in 1999 to that in 2000?
Your answer should be compact. 0.96. What is the ratio of the Primary completion rate (% of total enrollments) of Cyprus in 1999 to that in 2001?
Offer a terse response. 1.04. What is the ratio of the Primary completion rate (% of total enrollments) of Egypt, Arab Rep. in 1999 to that in 2001?
Ensure brevity in your answer.  1.03. What is the ratio of the Primary completion rate (% of total enrollments) of Ghana in 1999 to that in 2001?
Offer a very short reply. 1.02. What is the ratio of the Primary completion rate (% of total enrollments) in Egypt, Arab Rep. in 2000 to that in 2001?
Your answer should be very brief. 1.02. What is the ratio of the Primary completion rate (% of total enrollments) of Ghana in 2000 to that in 2001?
Offer a terse response. 1.06. What is the ratio of the Primary completion rate (% of total enrollments) of Tunisia in 2000 to that in 2001?
Ensure brevity in your answer.  1. What is the difference between the highest and the second highest Primary completion rate (% of total enrollments) of Cyprus?
Your answer should be very brief. 3.54. What is the difference between the highest and the second highest Primary completion rate (% of total enrollments) in Egypt, Arab Rep.?
Keep it short and to the point. 1.71. What is the difference between the highest and the second highest Primary completion rate (% of total enrollments) of Ghana?
Your answer should be compact. 0.32. What is the difference between the highest and the second highest Primary completion rate (% of total enrollments) in Tunisia?
Provide a succinct answer. 7.28. What is the difference between the highest and the lowest Primary completion rate (% of total enrollments) of Cyprus?
Ensure brevity in your answer.  28.85. What is the difference between the highest and the lowest Primary completion rate (% of total enrollments) in Egypt, Arab Rep.?
Your response must be concise. 56.41. What is the difference between the highest and the lowest Primary completion rate (% of total enrollments) of Ghana?
Your response must be concise. 5.79. What is the difference between the highest and the lowest Primary completion rate (% of total enrollments) in Tunisia?
Make the answer very short. 27.58. 